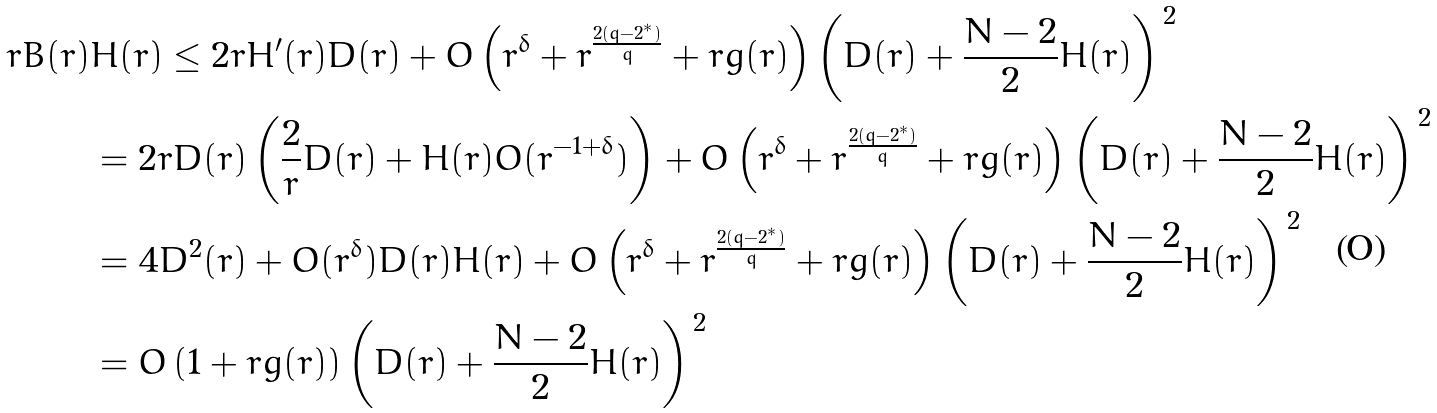<formula> <loc_0><loc_0><loc_500><loc_500>r B ( r ) & H ( r ) \leq 2 r H ^ { \prime } ( r ) D ( r ) + O \left ( r ^ { \delta } + r ^ { \frac { 2 ( q - 2 ^ { * } ) } { q } } + r g ( r ) \right ) \left ( D ( r ) + \frac { N - 2 } { 2 } H ( r ) \right ) ^ { \, 2 } \\ & = 2 r D ( r ) \left ( \frac { 2 } { r } D ( r ) + H ( r ) O ( r ^ { - 1 + \delta } ) \right ) + O \left ( r ^ { \delta } + r ^ { \frac { 2 ( q - 2 ^ { * } ) } { q } } + r g ( r ) \right ) \left ( D ( r ) + \frac { N - 2 } { 2 } H ( r ) \right ) ^ { \, 2 } \\ & = 4 D ^ { 2 } ( r ) + O ( r ^ { \delta } ) D ( r ) H ( r ) + O \left ( r ^ { \delta } + r ^ { \frac { 2 ( q - 2 ^ { * } ) } { q } } + r g ( r ) \right ) \left ( D ( r ) + \frac { N - 2 } { 2 } H ( r ) \right ) ^ { \, 2 } \\ & = O \left ( 1 + r g ( r ) \right ) \left ( D ( r ) + \frac { N - 2 } { 2 } H ( r ) \right ) ^ { \, 2 }</formula> 